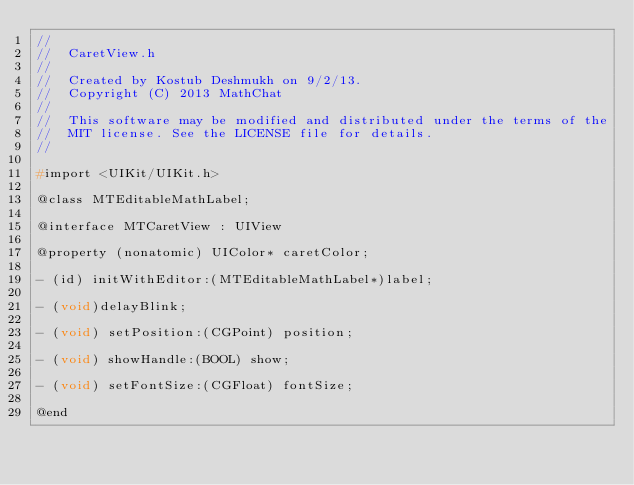Convert code to text. <code><loc_0><loc_0><loc_500><loc_500><_C_>//
//  CaretView.h
//
//  Created by Kostub Deshmukh on 9/2/13.
//  Copyright (C) 2013 MathChat
//   
//  This software may be modified and distributed under the terms of the
//  MIT license. See the LICENSE file for details.
//

#import <UIKit/UIKit.h>

@class MTEditableMathLabel;

@interface MTCaretView : UIView

@property (nonatomic) UIColor* caretColor;

- (id) initWithEditor:(MTEditableMathLabel*)label;

- (void)delayBlink;

- (void) setPosition:(CGPoint) position;

- (void) showHandle:(BOOL) show;

- (void) setFontSize:(CGFloat) fontSize;

@end

</code> 